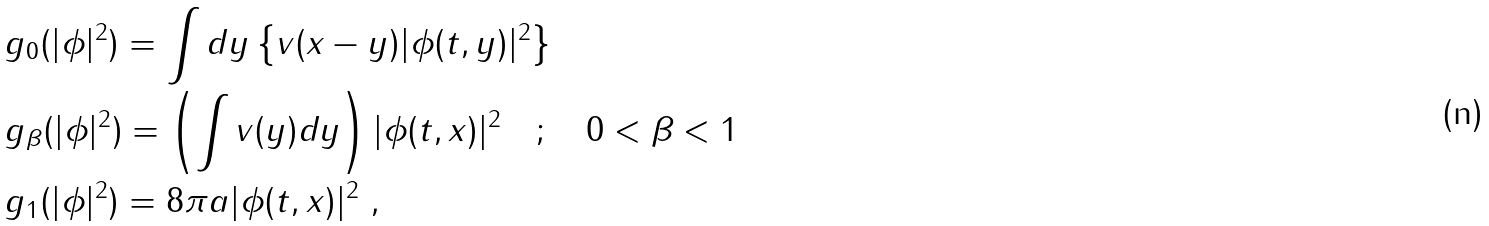Convert formula to latex. <formula><loc_0><loc_0><loc_500><loc_500>& g _ { 0 } ( | \phi | ^ { 2 } ) = \int d y \left \{ v ( x - y ) | \phi ( t , y ) | ^ { 2 } \right \} \\ & g _ { \beta } ( | \phi | ^ { 2 } ) = \left ( \int v ( y ) d y \right ) | \phi ( t , x ) | ^ { 2 } \quad ; \quad 0 < \beta < 1 \\ & g _ { 1 } ( | \phi | ^ { 2 } ) = 8 \pi a | \phi ( t , x ) | ^ { 2 } \ ,</formula> 